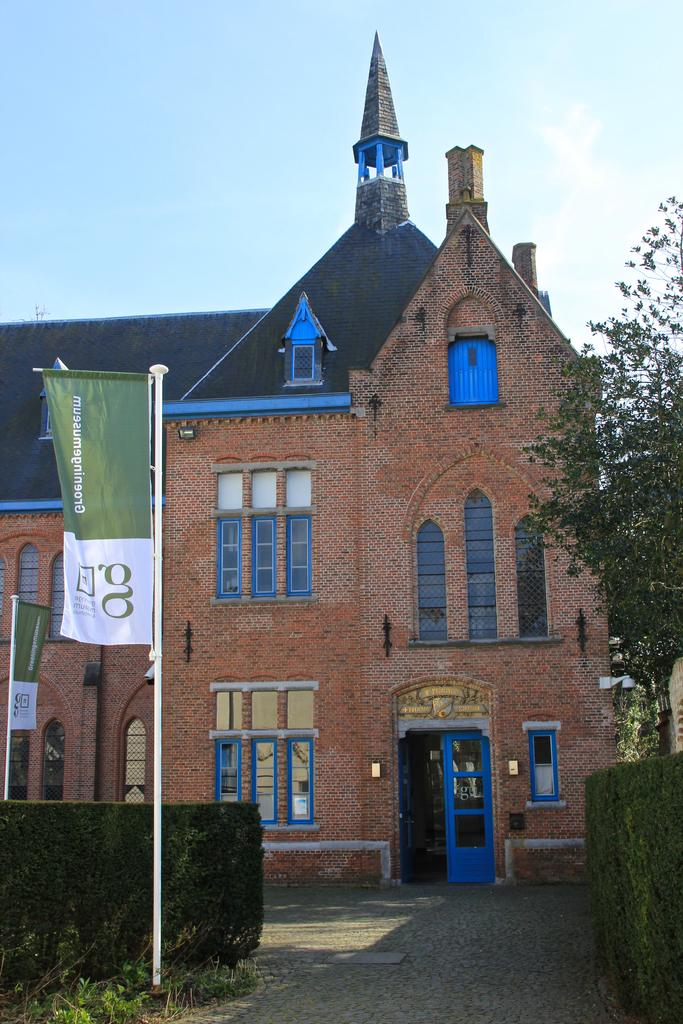What structure is the main subject of the image? There is a building in the image. What is located in front of the building? There are flags and trees in front of the building. What can be seen in the background of the image? The sky is visible in the background of the image. What is the weight of the harbor in the image? There is no harbor present in the image, so it is not possible to determine its weight. 